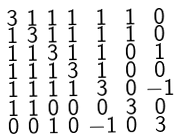Convert formula to latex. <formula><loc_0><loc_0><loc_500><loc_500>\begin{smallmatrix} 3 & 1 & 1 & 1 & 1 & 1 & 0 \\ 1 & 3 & 1 & 1 & 1 & 1 & 0 \\ 1 & 1 & 3 & 1 & 1 & 0 & 1 \\ 1 & 1 & 1 & 3 & 1 & 0 & 0 \\ 1 & 1 & 1 & 1 & 3 & 0 & - 1 \\ 1 & 1 & 0 & 0 & 0 & 3 & 0 \\ 0 & 0 & 1 & 0 & - 1 & 0 & 3 \end{smallmatrix}</formula> 